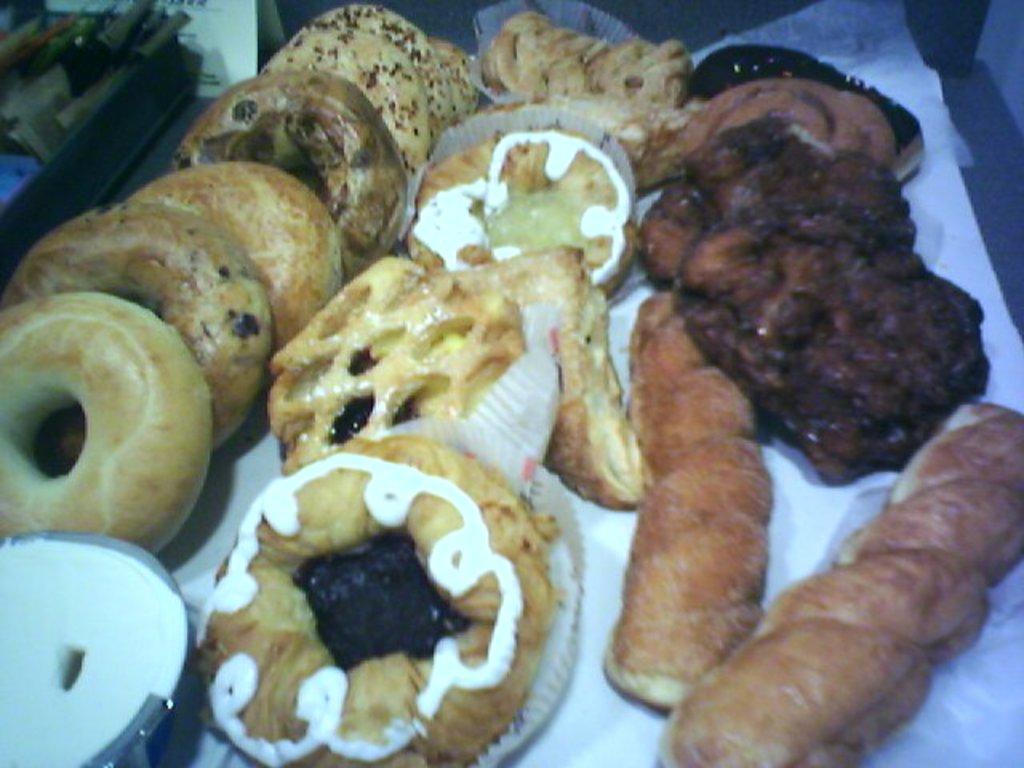Please provide a concise description of this image. In this picture we can see doughnuts. This is a chocolate sauce and this is a white cream applied on the doughnut. These are the paper plates. On the left side of the picture we can see on black tray and there are few bottles inside the tray. 